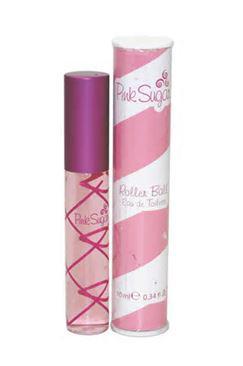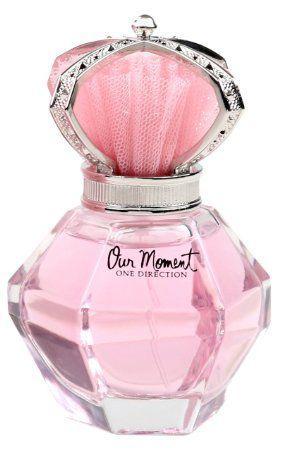The first image is the image on the left, the second image is the image on the right. Evaluate the accuracy of this statement regarding the images: "One image includes a single perfume bottle, which has a pink non-square top.". Is it true? Answer yes or no. Yes. The first image is the image on the left, the second image is the image on the right. Assess this claim about the two images: "In one of the images, there is a single bottle of perfume and it is pink.". Correct or not? Answer yes or no. Yes. 